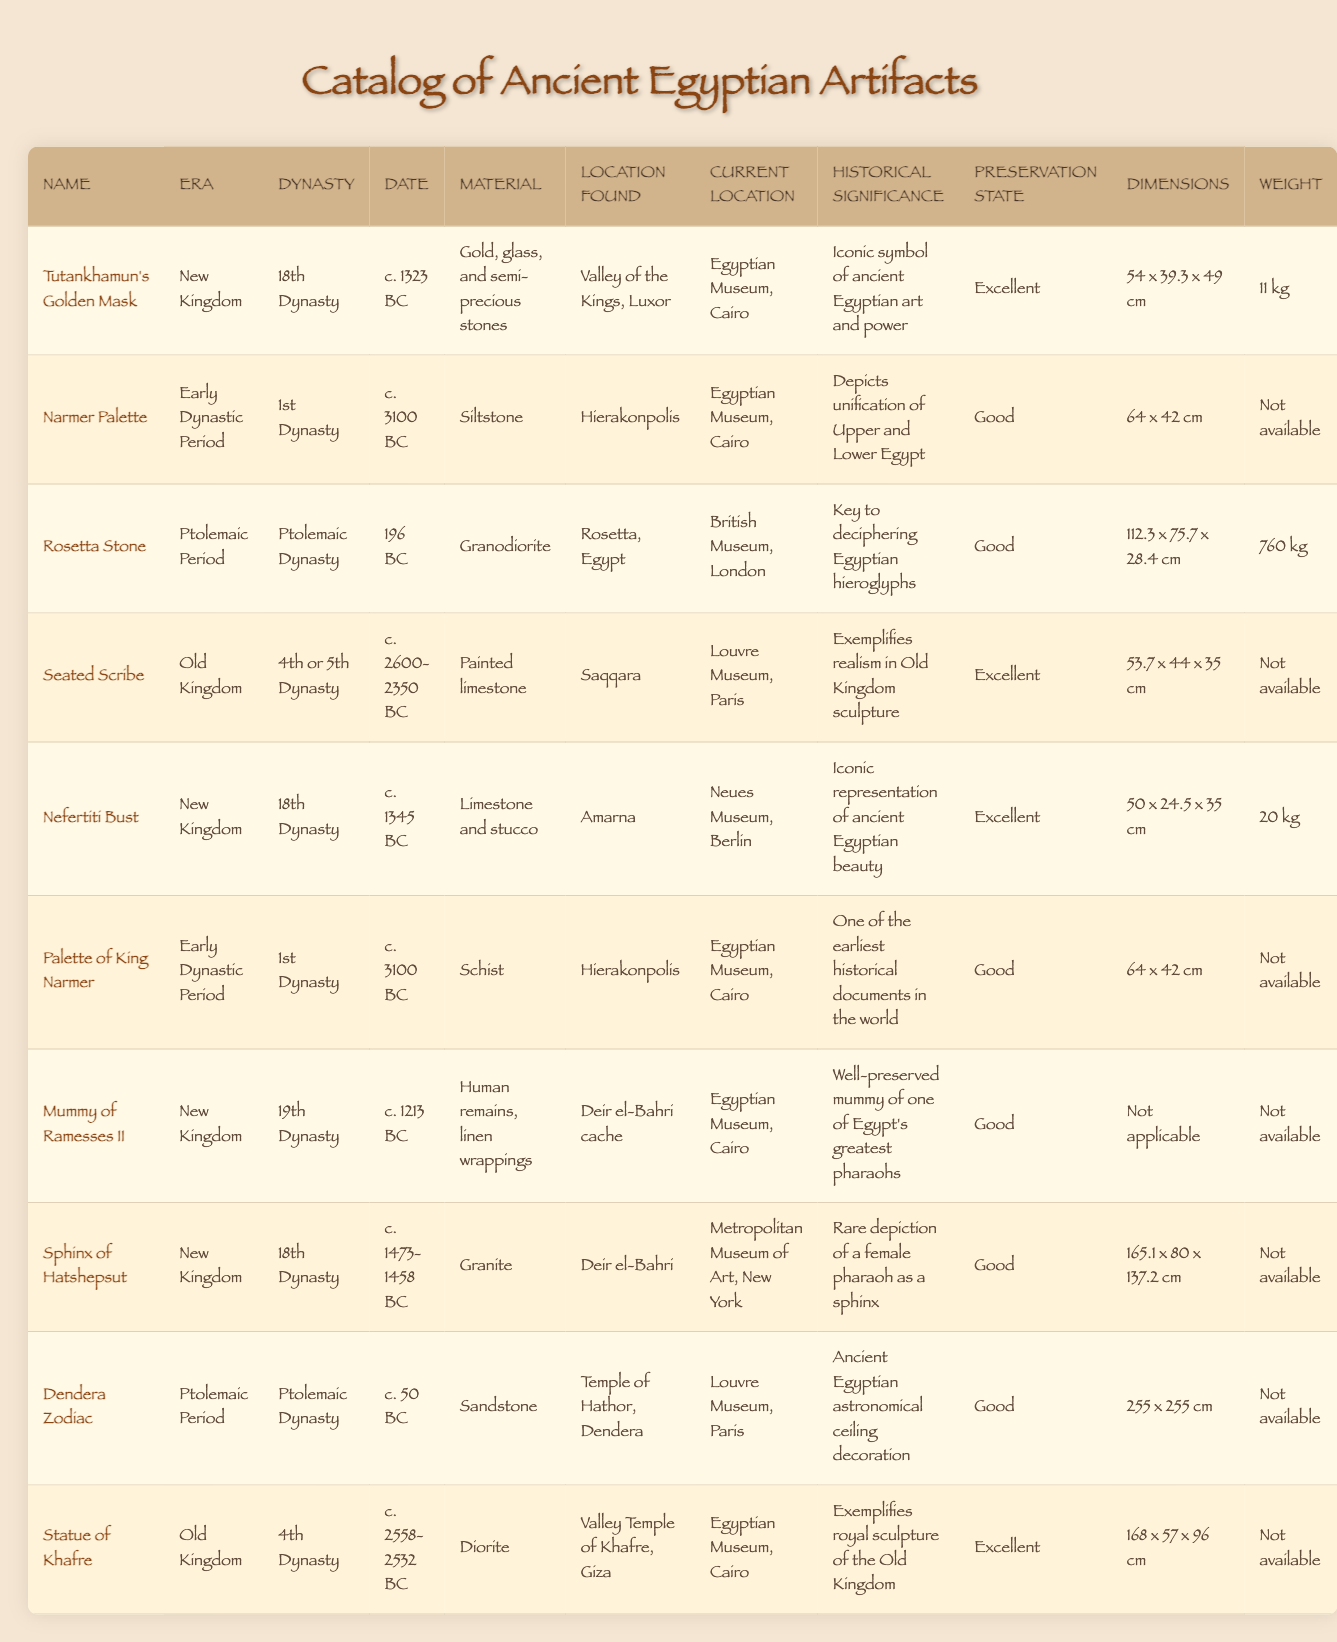What is the material of the Rosetta Stone? The table indicates that the Rosetta Stone is made of granodiorite.
Answer: Granodiorite Which artifacts belong to the New Kingdom era? Referring to the table, the artifacts listed under the New Kingdom era are "Tutankhamun's Golden Mask," "Nefertiti Bust," "Mummy of Ramesses II," and "Sphinx of Hatshepsut."
Answer: 4 artifacts What is the preservation state of the Seated Scribe? The table shows that the preservation state of the Seated Scribe is excellent.
Answer: Excellent Is the Narmer Palette made of siltstone? Yes, the table confirms that the Narmer Palette is made of siltstone.
Answer: Yes Which artifact weighs the most, and how much does it weigh? The table lists the weight of the Rosetta Stone as 760 kg, which is the highest among the artifacts.
Answer: 760 kg How many artifacts were found in the Louvre Museum? The table shows that there are two artifacts currently located in the Louvre Museum: the Seated Scribe and the Dendera Zodiac.
Answer: 2 artifacts What are the dimensions of the Statue of Khafre? According to the table, the dimensions of the Statue of Khafre are 168 x 57 x 96 cm.
Answer: 168 x 57 x 96 cm Is there any artifact that has dimensions listed as "Not applicable"? The table shows that the Mummy of Ramesses II has dimensions listed as "Not applicable."
Answer: Yes Which two artifacts were found in Hierakonpolis? The artifacts from Hierakonpolis listed in the table are the Narmer Palette and the Palette of King Narmer.
Answer: 2 artifacts What is the historical significance of the Dendera Zodiac? The table indicates that the Dendera Zodiac is significant as an ancient Egyptian astronomical ceiling decoration.
Answer: Astronomical decoration 